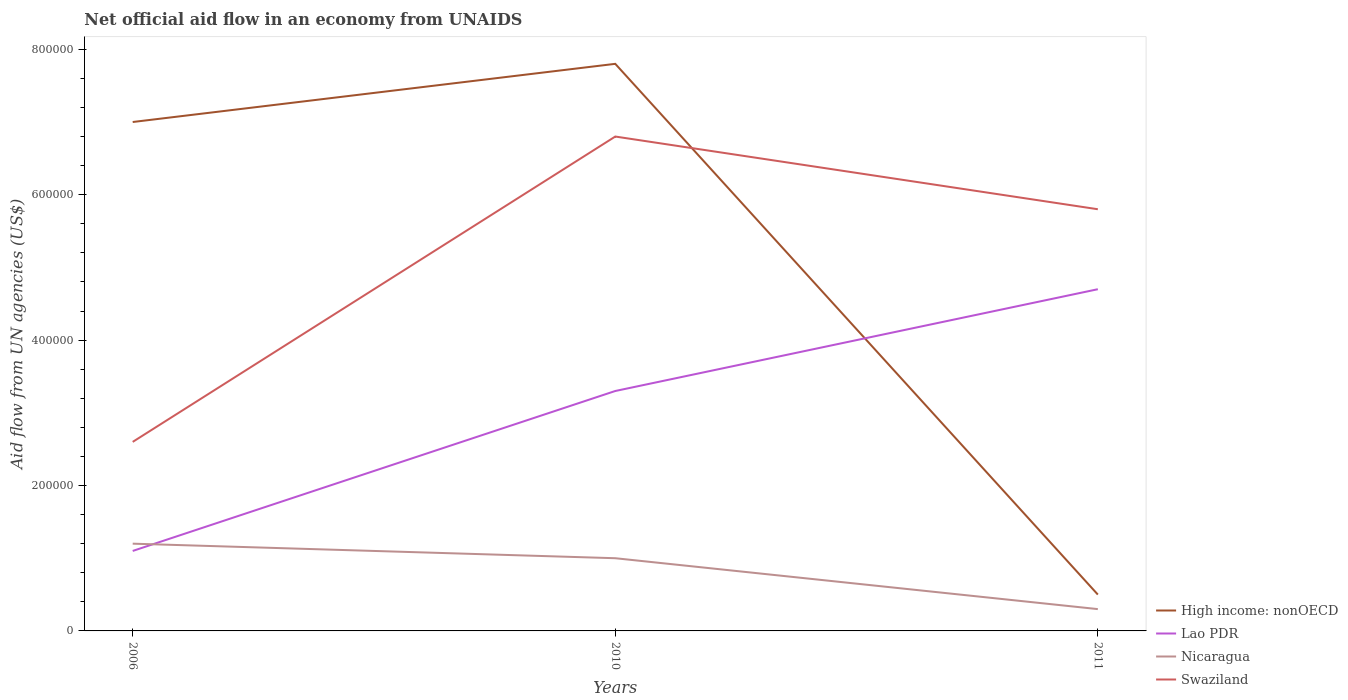How many different coloured lines are there?
Offer a terse response. 4. Is the number of lines equal to the number of legend labels?
Make the answer very short. Yes. Across all years, what is the maximum net official aid flow in Nicaragua?
Provide a succinct answer. 3.00e+04. What is the difference between the highest and the second highest net official aid flow in High income: nonOECD?
Your answer should be very brief. 7.30e+05. What is the difference between the highest and the lowest net official aid flow in High income: nonOECD?
Keep it short and to the point. 2. Is the net official aid flow in Nicaragua strictly greater than the net official aid flow in Swaziland over the years?
Offer a terse response. Yes. How many lines are there?
Give a very brief answer. 4. How many years are there in the graph?
Ensure brevity in your answer.  3. What is the difference between two consecutive major ticks on the Y-axis?
Keep it short and to the point. 2.00e+05. Does the graph contain grids?
Give a very brief answer. No. How many legend labels are there?
Provide a succinct answer. 4. How are the legend labels stacked?
Give a very brief answer. Vertical. What is the title of the graph?
Provide a succinct answer. Net official aid flow in an economy from UNAIDS. What is the label or title of the Y-axis?
Keep it short and to the point. Aid flow from UN agencies (US$). What is the Aid flow from UN agencies (US$) of High income: nonOECD in 2006?
Keep it short and to the point. 7.00e+05. What is the Aid flow from UN agencies (US$) in Nicaragua in 2006?
Provide a succinct answer. 1.20e+05. What is the Aid flow from UN agencies (US$) of Swaziland in 2006?
Provide a succinct answer. 2.60e+05. What is the Aid flow from UN agencies (US$) of High income: nonOECD in 2010?
Ensure brevity in your answer.  7.80e+05. What is the Aid flow from UN agencies (US$) of Swaziland in 2010?
Offer a terse response. 6.80e+05. What is the Aid flow from UN agencies (US$) in Lao PDR in 2011?
Provide a succinct answer. 4.70e+05. What is the Aid flow from UN agencies (US$) in Nicaragua in 2011?
Ensure brevity in your answer.  3.00e+04. What is the Aid flow from UN agencies (US$) of Swaziland in 2011?
Keep it short and to the point. 5.80e+05. Across all years, what is the maximum Aid flow from UN agencies (US$) of High income: nonOECD?
Offer a terse response. 7.80e+05. Across all years, what is the maximum Aid flow from UN agencies (US$) of Nicaragua?
Offer a very short reply. 1.20e+05. Across all years, what is the maximum Aid flow from UN agencies (US$) of Swaziland?
Keep it short and to the point. 6.80e+05. Across all years, what is the minimum Aid flow from UN agencies (US$) in High income: nonOECD?
Your answer should be compact. 5.00e+04. What is the total Aid flow from UN agencies (US$) of High income: nonOECD in the graph?
Offer a very short reply. 1.53e+06. What is the total Aid flow from UN agencies (US$) in Lao PDR in the graph?
Make the answer very short. 9.10e+05. What is the total Aid flow from UN agencies (US$) of Nicaragua in the graph?
Your answer should be compact. 2.50e+05. What is the total Aid flow from UN agencies (US$) in Swaziland in the graph?
Offer a very short reply. 1.52e+06. What is the difference between the Aid flow from UN agencies (US$) in Lao PDR in 2006 and that in 2010?
Your answer should be compact. -2.20e+05. What is the difference between the Aid flow from UN agencies (US$) of Nicaragua in 2006 and that in 2010?
Offer a very short reply. 2.00e+04. What is the difference between the Aid flow from UN agencies (US$) in Swaziland in 2006 and that in 2010?
Give a very brief answer. -4.20e+05. What is the difference between the Aid flow from UN agencies (US$) of High income: nonOECD in 2006 and that in 2011?
Give a very brief answer. 6.50e+05. What is the difference between the Aid flow from UN agencies (US$) in Lao PDR in 2006 and that in 2011?
Offer a terse response. -3.60e+05. What is the difference between the Aid flow from UN agencies (US$) in Swaziland in 2006 and that in 2011?
Provide a succinct answer. -3.20e+05. What is the difference between the Aid flow from UN agencies (US$) of High income: nonOECD in 2010 and that in 2011?
Offer a very short reply. 7.30e+05. What is the difference between the Aid flow from UN agencies (US$) in Swaziland in 2010 and that in 2011?
Provide a short and direct response. 1.00e+05. What is the difference between the Aid flow from UN agencies (US$) in High income: nonOECD in 2006 and the Aid flow from UN agencies (US$) in Nicaragua in 2010?
Provide a succinct answer. 6.00e+05. What is the difference between the Aid flow from UN agencies (US$) in Lao PDR in 2006 and the Aid flow from UN agencies (US$) in Nicaragua in 2010?
Ensure brevity in your answer.  10000. What is the difference between the Aid flow from UN agencies (US$) in Lao PDR in 2006 and the Aid flow from UN agencies (US$) in Swaziland in 2010?
Your answer should be compact. -5.70e+05. What is the difference between the Aid flow from UN agencies (US$) in Nicaragua in 2006 and the Aid flow from UN agencies (US$) in Swaziland in 2010?
Your answer should be very brief. -5.60e+05. What is the difference between the Aid flow from UN agencies (US$) in High income: nonOECD in 2006 and the Aid flow from UN agencies (US$) in Nicaragua in 2011?
Offer a very short reply. 6.70e+05. What is the difference between the Aid flow from UN agencies (US$) of High income: nonOECD in 2006 and the Aid flow from UN agencies (US$) of Swaziland in 2011?
Provide a short and direct response. 1.20e+05. What is the difference between the Aid flow from UN agencies (US$) in Lao PDR in 2006 and the Aid flow from UN agencies (US$) in Swaziland in 2011?
Give a very brief answer. -4.70e+05. What is the difference between the Aid flow from UN agencies (US$) of Nicaragua in 2006 and the Aid flow from UN agencies (US$) of Swaziland in 2011?
Your answer should be very brief. -4.60e+05. What is the difference between the Aid flow from UN agencies (US$) in High income: nonOECD in 2010 and the Aid flow from UN agencies (US$) in Nicaragua in 2011?
Your answer should be compact. 7.50e+05. What is the difference between the Aid flow from UN agencies (US$) in High income: nonOECD in 2010 and the Aid flow from UN agencies (US$) in Swaziland in 2011?
Your answer should be compact. 2.00e+05. What is the difference between the Aid flow from UN agencies (US$) in Nicaragua in 2010 and the Aid flow from UN agencies (US$) in Swaziland in 2011?
Ensure brevity in your answer.  -4.80e+05. What is the average Aid flow from UN agencies (US$) of High income: nonOECD per year?
Provide a succinct answer. 5.10e+05. What is the average Aid flow from UN agencies (US$) in Lao PDR per year?
Provide a short and direct response. 3.03e+05. What is the average Aid flow from UN agencies (US$) in Nicaragua per year?
Provide a short and direct response. 8.33e+04. What is the average Aid flow from UN agencies (US$) of Swaziland per year?
Provide a succinct answer. 5.07e+05. In the year 2006, what is the difference between the Aid flow from UN agencies (US$) of High income: nonOECD and Aid flow from UN agencies (US$) of Lao PDR?
Your answer should be compact. 5.90e+05. In the year 2006, what is the difference between the Aid flow from UN agencies (US$) of High income: nonOECD and Aid flow from UN agencies (US$) of Nicaragua?
Keep it short and to the point. 5.80e+05. In the year 2006, what is the difference between the Aid flow from UN agencies (US$) in Lao PDR and Aid flow from UN agencies (US$) in Nicaragua?
Your answer should be very brief. -10000. In the year 2006, what is the difference between the Aid flow from UN agencies (US$) of Nicaragua and Aid flow from UN agencies (US$) of Swaziland?
Your answer should be very brief. -1.40e+05. In the year 2010, what is the difference between the Aid flow from UN agencies (US$) in High income: nonOECD and Aid flow from UN agencies (US$) in Nicaragua?
Give a very brief answer. 6.80e+05. In the year 2010, what is the difference between the Aid flow from UN agencies (US$) of High income: nonOECD and Aid flow from UN agencies (US$) of Swaziland?
Your answer should be compact. 1.00e+05. In the year 2010, what is the difference between the Aid flow from UN agencies (US$) of Lao PDR and Aid flow from UN agencies (US$) of Swaziland?
Give a very brief answer. -3.50e+05. In the year 2010, what is the difference between the Aid flow from UN agencies (US$) in Nicaragua and Aid flow from UN agencies (US$) in Swaziland?
Provide a short and direct response. -5.80e+05. In the year 2011, what is the difference between the Aid flow from UN agencies (US$) in High income: nonOECD and Aid flow from UN agencies (US$) in Lao PDR?
Your answer should be very brief. -4.20e+05. In the year 2011, what is the difference between the Aid flow from UN agencies (US$) in High income: nonOECD and Aid flow from UN agencies (US$) in Swaziland?
Make the answer very short. -5.30e+05. In the year 2011, what is the difference between the Aid flow from UN agencies (US$) of Nicaragua and Aid flow from UN agencies (US$) of Swaziland?
Your response must be concise. -5.50e+05. What is the ratio of the Aid flow from UN agencies (US$) of High income: nonOECD in 2006 to that in 2010?
Ensure brevity in your answer.  0.9. What is the ratio of the Aid flow from UN agencies (US$) of Nicaragua in 2006 to that in 2010?
Offer a very short reply. 1.2. What is the ratio of the Aid flow from UN agencies (US$) of Swaziland in 2006 to that in 2010?
Give a very brief answer. 0.38. What is the ratio of the Aid flow from UN agencies (US$) in High income: nonOECD in 2006 to that in 2011?
Your answer should be very brief. 14. What is the ratio of the Aid flow from UN agencies (US$) of Lao PDR in 2006 to that in 2011?
Give a very brief answer. 0.23. What is the ratio of the Aid flow from UN agencies (US$) of Nicaragua in 2006 to that in 2011?
Make the answer very short. 4. What is the ratio of the Aid flow from UN agencies (US$) in Swaziland in 2006 to that in 2011?
Offer a terse response. 0.45. What is the ratio of the Aid flow from UN agencies (US$) in Lao PDR in 2010 to that in 2011?
Give a very brief answer. 0.7. What is the ratio of the Aid flow from UN agencies (US$) of Nicaragua in 2010 to that in 2011?
Give a very brief answer. 3.33. What is the ratio of the Aid flow from UN agencies (US$) of Swaziland in 2010 to that in 2011?
Give a very brief answer. 1.17. What is the difference between the highest and the second highest Aid flow from UN agencies (US$) in High income: nonOECD?
Provide a short and direct response. 8.00e+04. What is the difference between the highest and the second highest Aid flow from UN agencies (US$) of Swaziland?
Make the answer very short. 1.00e+05. What is the difference between the highest and the lowest Aid flow from UN agencies (US$) in High income: nonOECD?
Ensure brevity in your answer.  7.30e+05. What is the difference between the highest and the lowest Aid flow from UN agencies (US$) in Lao PDR?
Provide a short and direct response. 3.60e+05. 